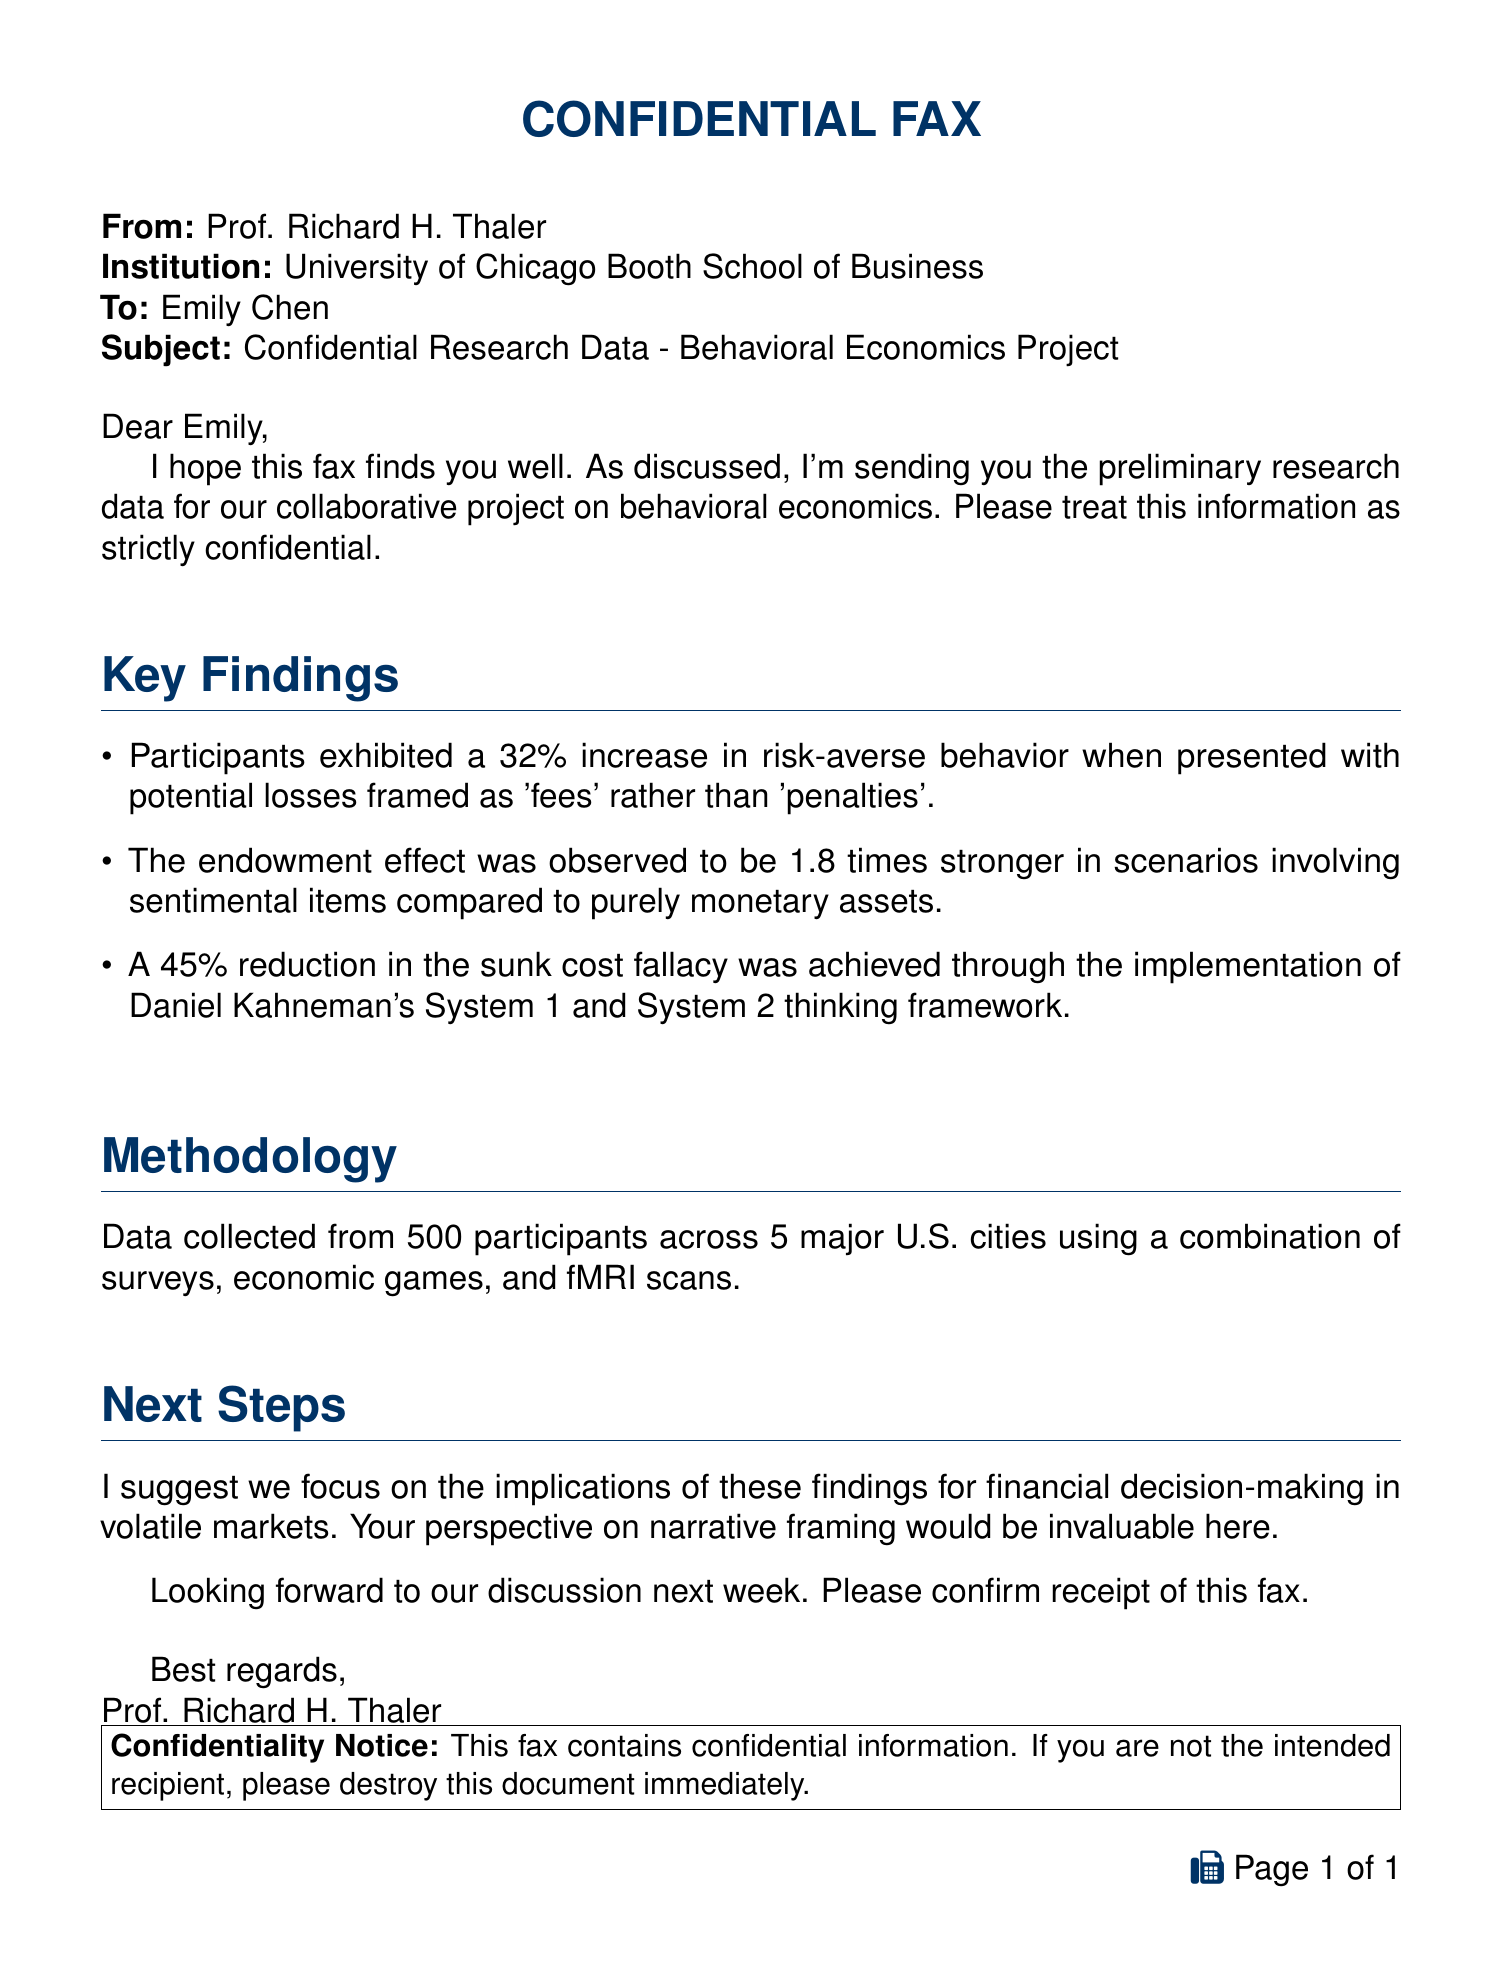What is the sender's name? The sender's name is mentioned in the fax as Prof. Richard H. Thaler.
Answer: Prof. Richard H. Thaler What percentage increase in risk-averse behavior was observed? The document states that there was a 32% increase in risk-averse behavior.
Answer: 32% How many participants were involved in the study? The document indicates that data was collected from 500 participants.
Answer: 500 Which economic theory framework reduced the sunk cost fallacy? The methodology mentions the implementation of Daniel Kahneman's System 1 and System 2 thinking framework.
Answer: System 1 and System 2 What is the endowment effect strength in sentimental items compared to monetary assets? The document states that the endowment effect was observed to be 1.8 times stronger in sentimental items.
Answer: 1.8 times To whom is the fax addressed? The recipient's name is provided in the fax as Emily Chen.
Answer: Emily Chen What type of document is this? The document is classified as a confidential fax.
Answer: confidential fax What cities were included in the participant data collection? The document mentions that data was collected from participants across 5 major U.S. cities.
Answer: 5 major U.S. cities What are the next steps suggested by the sender? The sender suggests focusing on the implications of the findings for financial decision-making in volatile markets.
Answer: implications for financial decision-making 